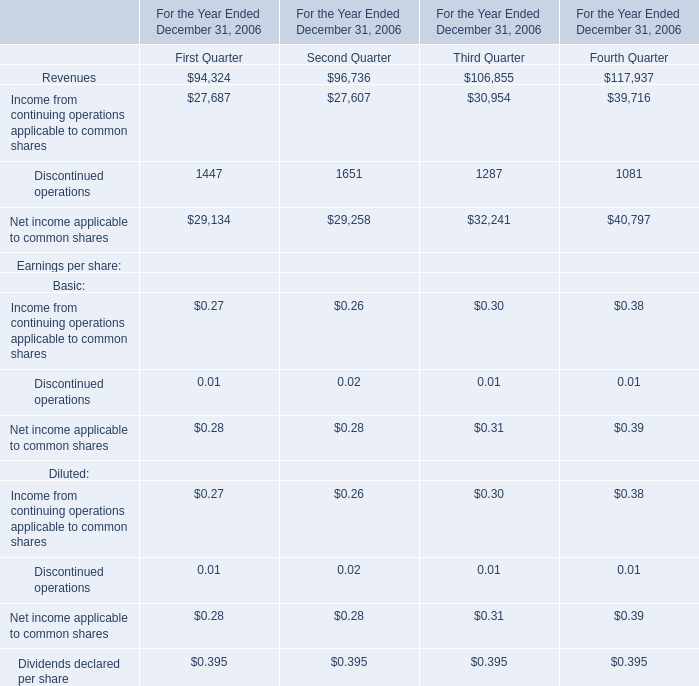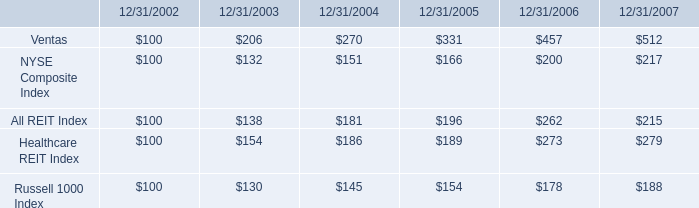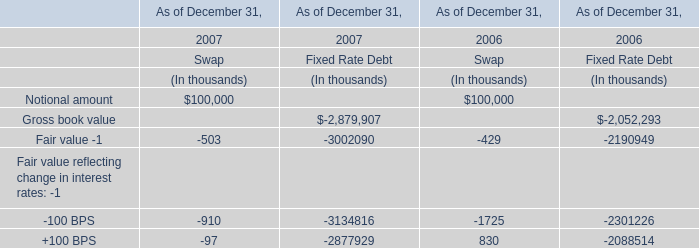what was the 5 year return on ventas common stock? 
Computations: ((512 - 100) / 100)
Answer: 4.12. 